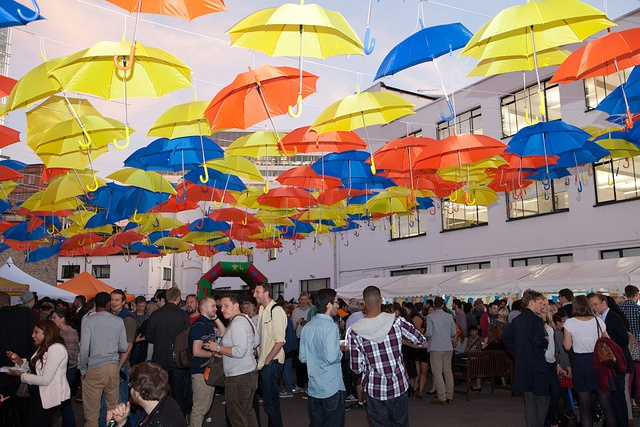Describe the objects in this image and their specific colors. I can see umbrella in blue, olive, brown, and red tones, people in blue, black, darkgray, maroon, and gray tones, people in blue, black, darkgray, gray, and maroon tones, umbrella in blue, khaki, gold, and beige tones, and umbrella in blue, khaki, beige, and gold tones in this image. 